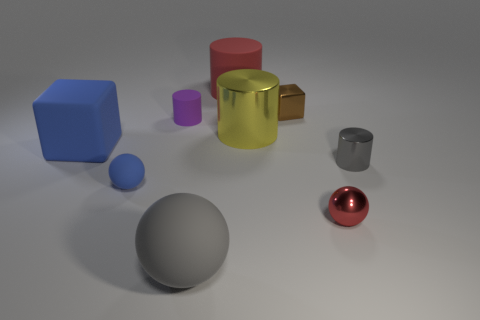Subtract 1 cylinders. How many cylinders are left? 3 Add 1 big brown matte objects. How many objects exist? 10 Subtract all cubes. How many objects are left? 7 Add 3 gray cylinders. How many gray cylinders are left? 4 Add 8 large shiny things. How many large shiny things exist? 9 Subtract 1 blue spheres. How many objects are left? 8 Subtract all large metal cylinders. Subtract all rubber spheres. How many objects are left? 6 